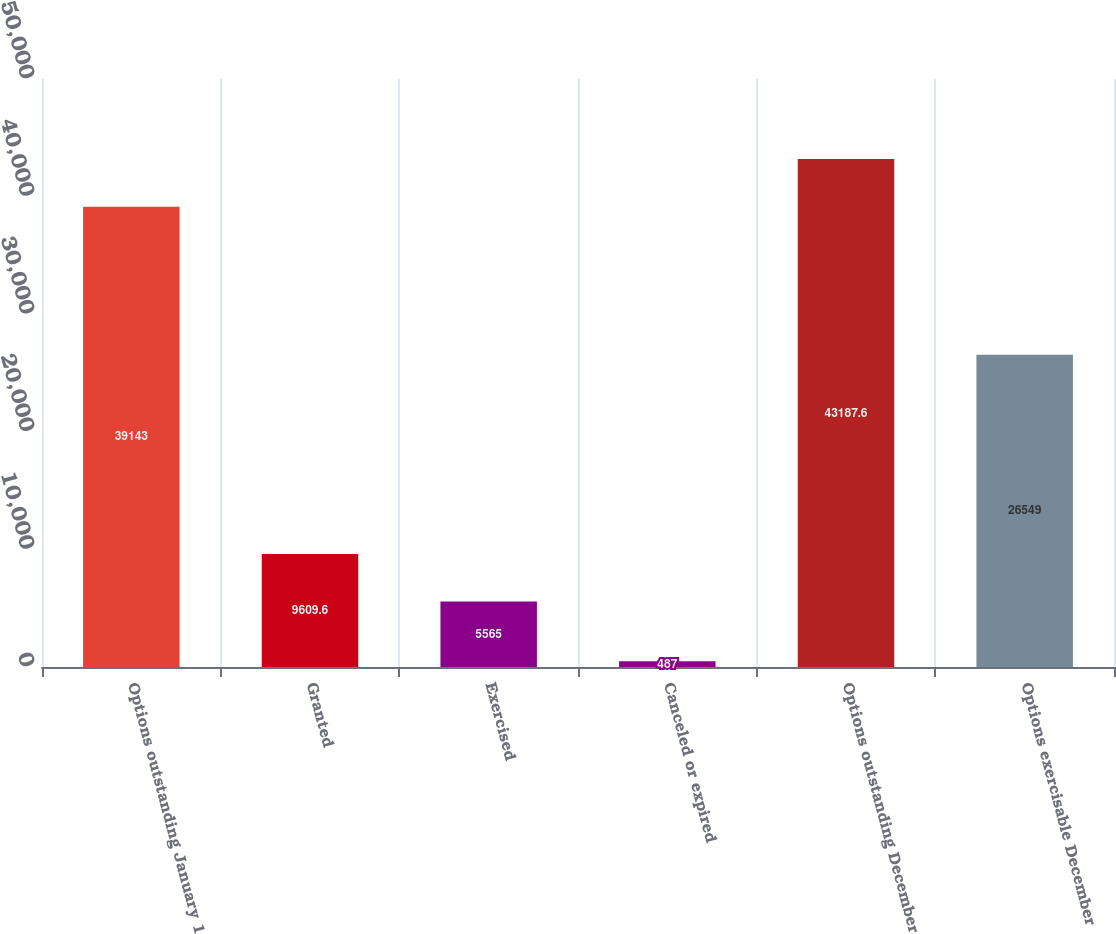Convert chart. <chart><loc_0><loc_0><loc_500><loc_500><bar_chart><fcel>Options outstanding January 1<fcel>Granted<fcel>Exercised<fcel>Canceled or expired<fcel>Options outstanding December<fcel>Options exercisable December<nl><fcel>39143<fcel>9609.6<fcel>5565<fcel>487<fcel>43187.6<fcel>26549<nl></chart> 